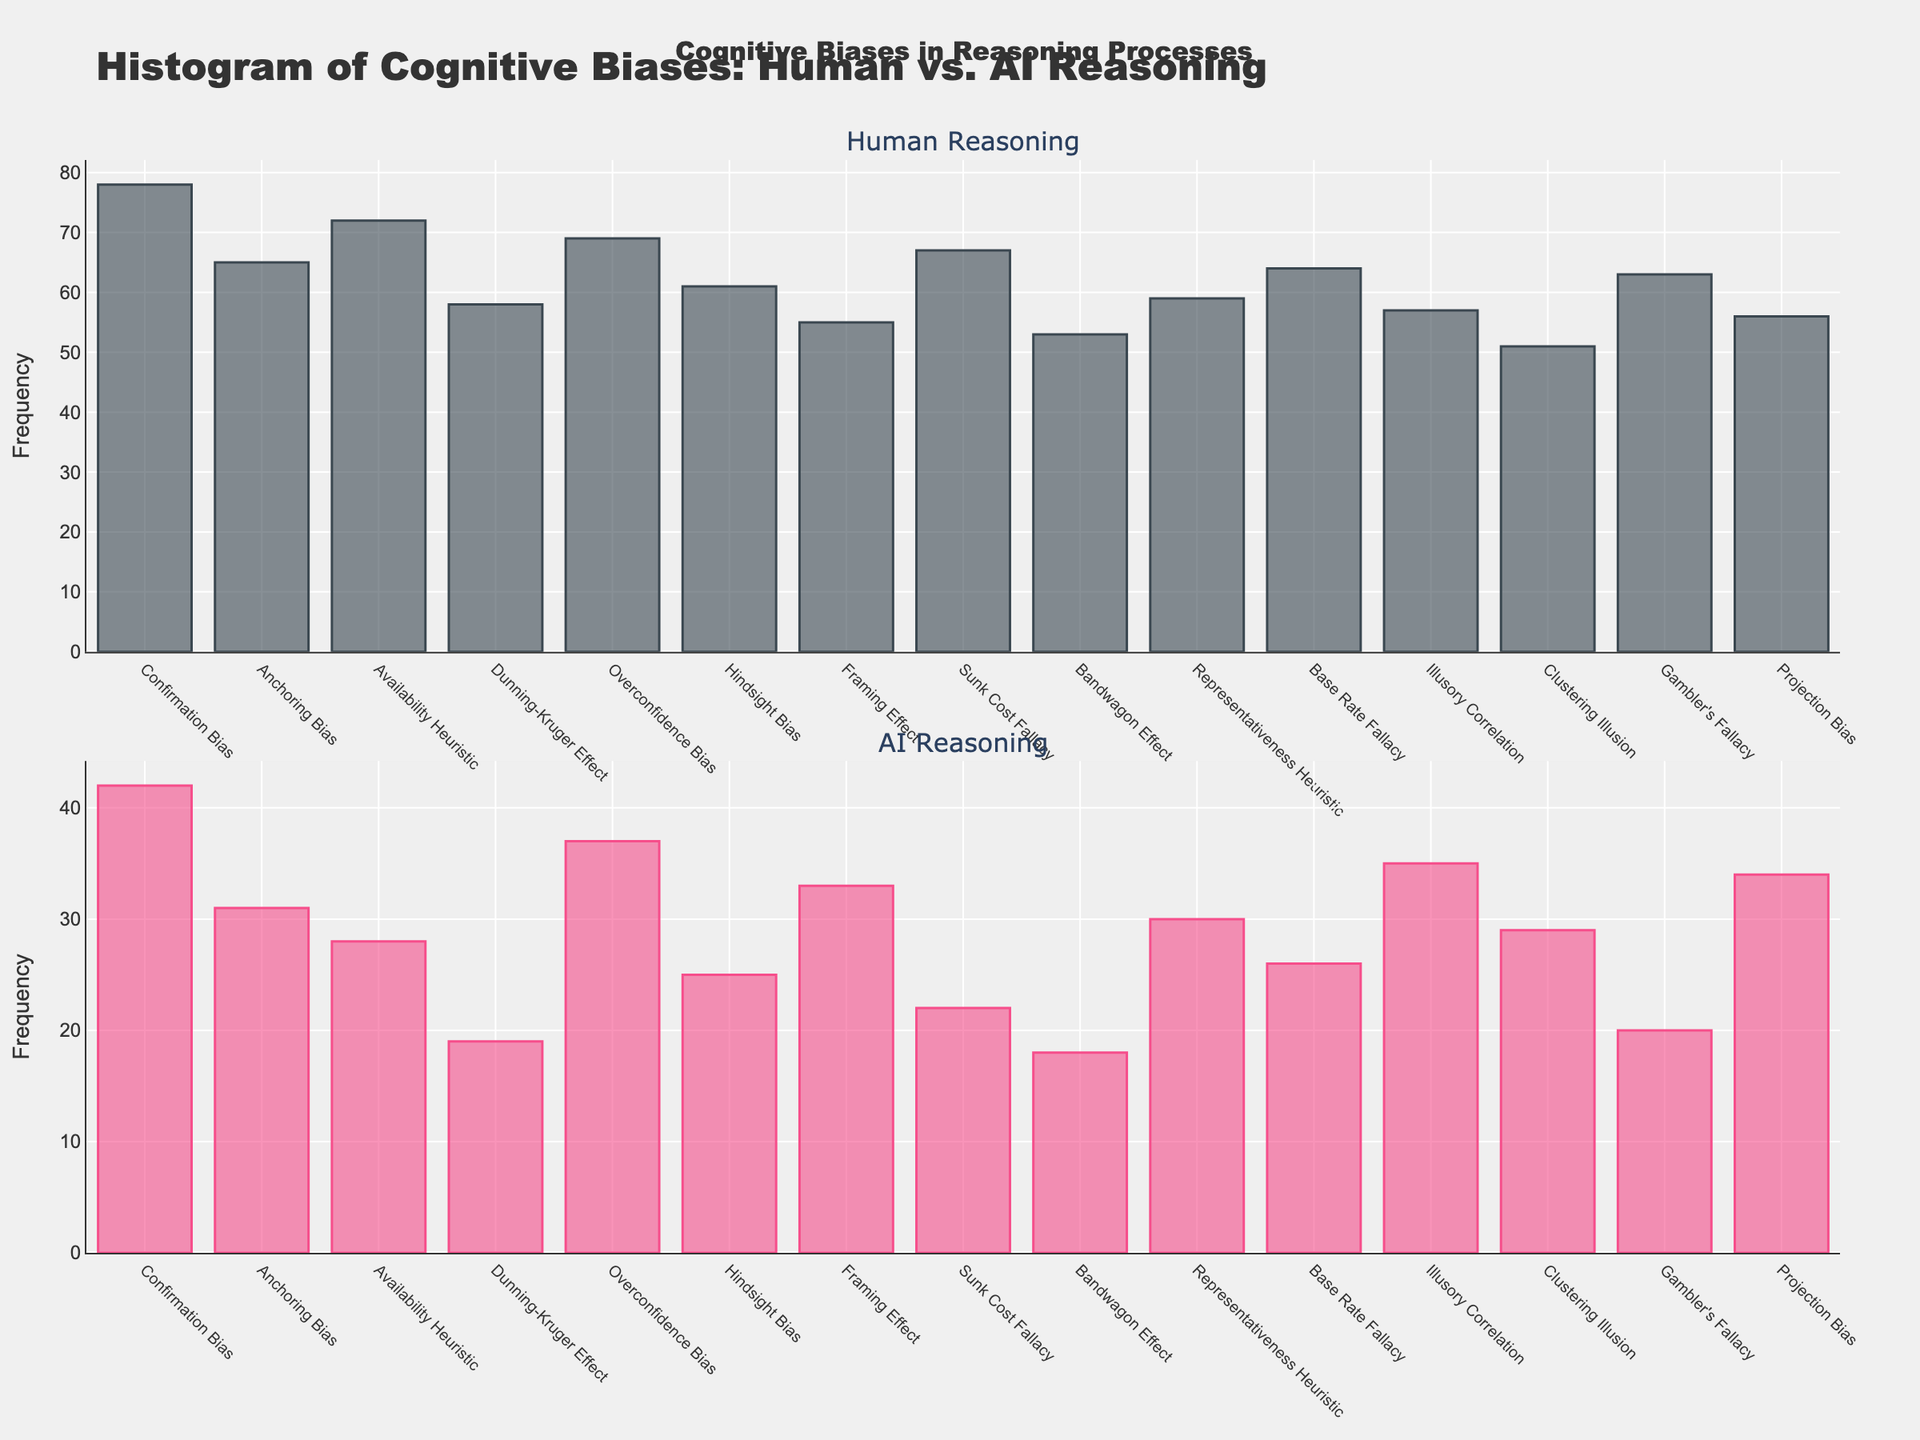Which bias has the highest frequency in human reasoning? The highest bar in the "Human Reasoning" subplot indicates the bias with the highest frequency. Confirmation Bias has the tallest bar with a frequency of 78.
Answer: Confirmation Bias What is the total frequency of all biases observed in AI reasoning? Sum the frequencies of all biases observed in the "AI Reasoning" subplot: 42 + 31 + 28 + 19 + 37 + 25 + 33 + 22 + 18 + 30 + 26 + 35 + 29 + 20 + 34 = 409.
Answer: 409 How many biases have a higher frequency in AI reasoning than in human reasoning? Compare each bias frequency between "AI Reasoning" and "Human Reasoning." None of the biases have a higher frequency in AI reasoning when compared to human reasoning.
Answer: 0 What is the average frequency of Dunning-Kruger Effect in human and AI reasoning? Calculate the average frequency by summing the Dunning-Kruger Effect frequencies from both subplots and dividing by 2: (58 + 19) / 2 = 38.5.
Answer: 38.5 What is the total frequency of cognitive biases that are above 60 in human reasoning? Sum the frequencies from "Human Reasoning" subplot that are above 60: 78 (Confirmation Bias) + 65 (Anchoring Bias) + 72 (Availability Heuristic) + 69 (Overconfidence Bias) + 61 (Hindsight Bias) + 67 (Sunk Cost Fallacy) + 63 (Gambler's Fallacy) = 475.
Answer: 475 Which bias type has the most significant reduction from human frequency to AI frequency? Calculate the reduction for each bias by subtracting AI frequency from human frequency. Confirmation Bias has the largest reduction of 78 - 42 = 36.
Answer: Confirmation Bias Compare the frequencies of Overconfidence Bias and Hindsight Bias in human reasoning. Which one is higher? Compare the heights of the bars for Overconfidence Bias and Hindsight Bias in "Human Reasoning" subplot. Overconfidence Bias has a higher bar with a frequency of 69 compared to Hindsight Bias at 61.
Answer: Overconfidence Bias What is the combined frequency of Bandwagon Effect and Representativeness Heuristic in both human and AI reasoning? Sum the frequencies of Bandwagon Effect and Representativeness Heuristic in both subplots: (53+18) + (59+30) = 71 + 89 = 160.
Answer: 160 